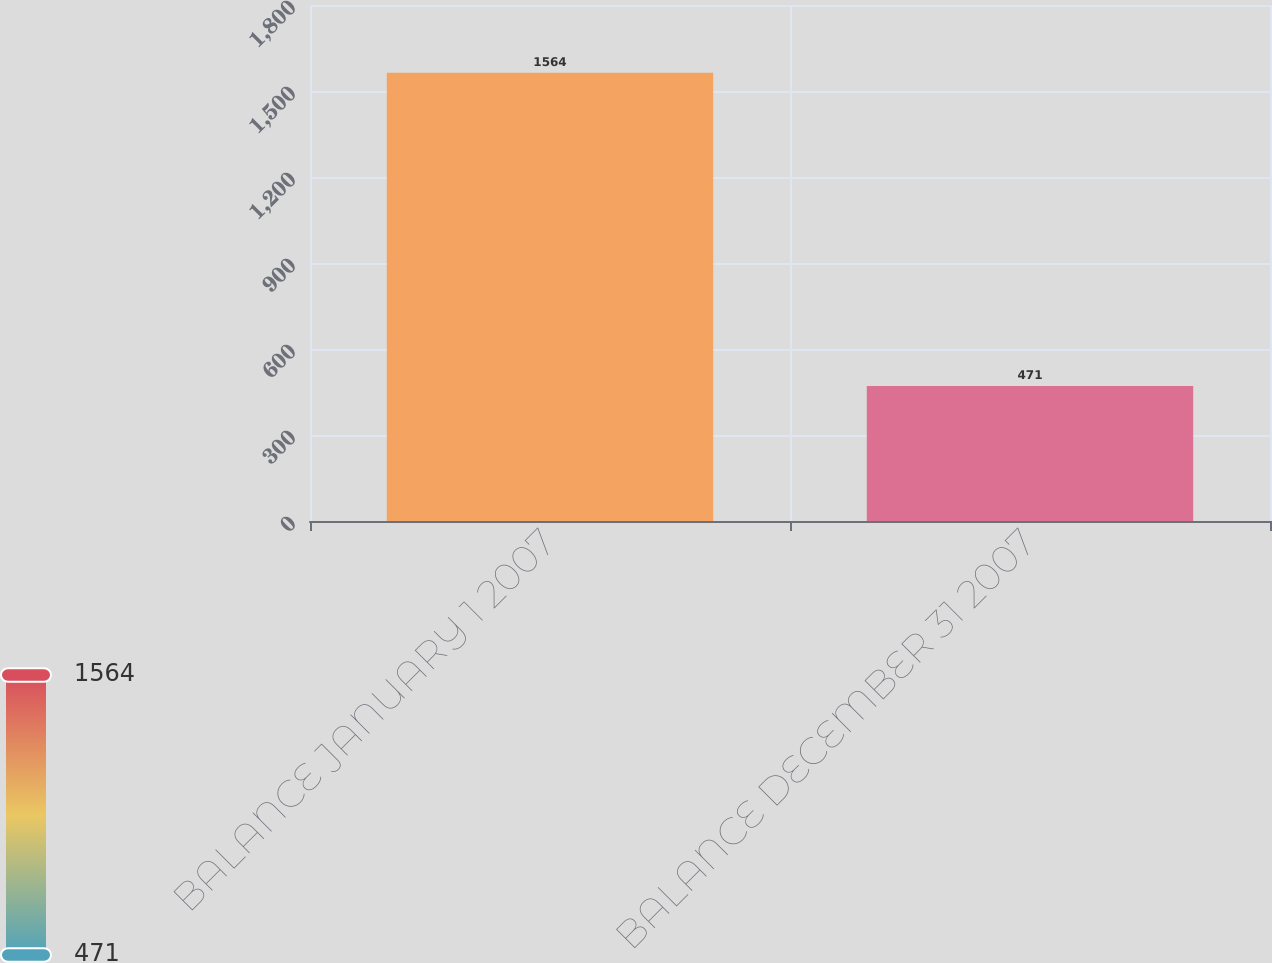Convert chart to OTSL. <chart><loc_0><loc_0><loc_500><loc_500><bar_chart><fcel>BALANCE JANUARY 1 2007<fcel>BALANCE DECEMBER 31 2007<nl><fcel>1564<fcel>471<nl></chart> 